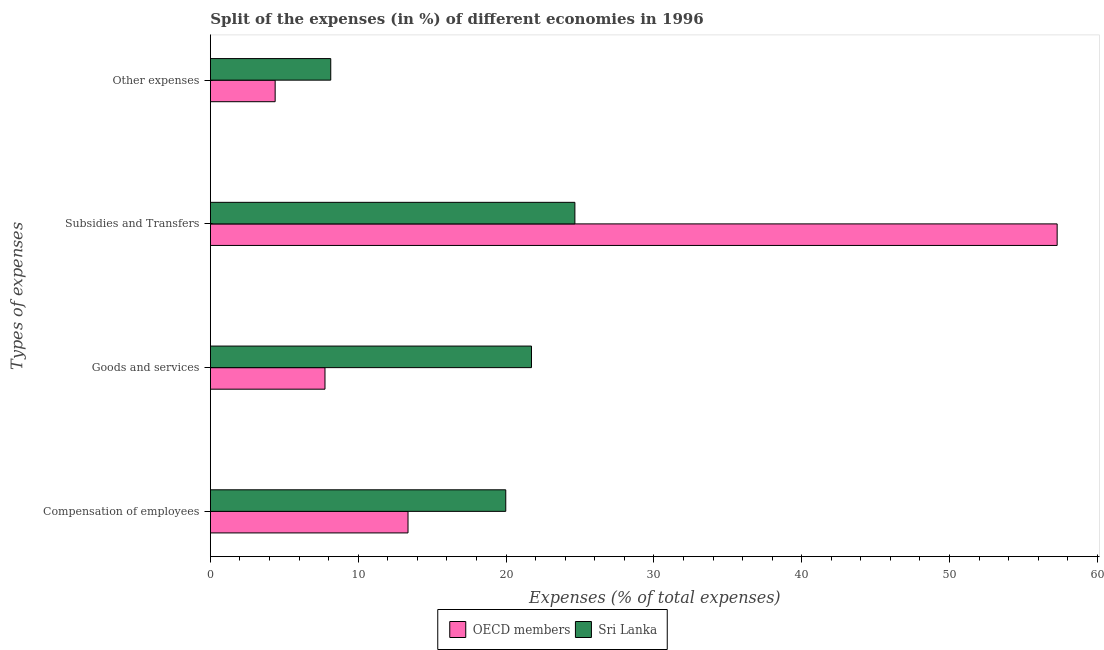How many groups of bars are there?
Your response must be concise. 4. Are the number of bars on each tick of the Y-axis equal?
Give a very brief answer. Yes. How many bars are there on the 3rd tick from the top?
Your answer should be very brief. 2. How many bars are there on the 4th tick from the bottom?
Keep it short and to the point. 2. What is the label of the 2nd group of bars from the top?
Your answer should be compact. Subsidies and Transfers. What is the percentage of amount spent on other expenses in Sri Lanka?
Your answer should be very brief. 8.14. Across all countries, what is the maximum percentage of amount spent on goods and services?
Offer a terse response. 21.72. Across all countries, what is the minimum percentage of amount spent on other expenses?
Make the answer very short. 4.38. In which country was the percentage of amount spent on compensation of employees maximum?
Your answer should be very brief. Sri Lanka. In which country was the percentage of amount spent on other expenses minimum?
Keep it short and to the point. OECD members. What is the total percentage of amount spent on subsidies in the graph?
Provide a short and direct response. 81.94. What is the difference between the percentage of amount spent on compensation of employees in OECD members and that in Sri Lanka?
Your answer should be compact. -6.61. What is the difference between the percentage of amount spent on goods and services in OECD members and the percentage of amount spent on other expenses in Sri Lanka?
Provide a short and direct response. -0.39. What is the average percentage of amount spent on goods and services per country?
Your answer should be compact. 14.74. What is the difference between the percentage of amount spent on goods and services and percentage of amount spent on compensation of employees in Sri Lanka?
Give a very brief answer. 1.74. What is the ratio of the percentage of amount spent on subsidies in OECD members to that in Sri Lanka?
Your answer should be compact. 2.32. What is the difference between the highest and the second highest percentage of amount spent on goods and services?
Give a very brief answer. 13.97. What is the difference between the highest and the lowest percentage of amount spent on goods and services?
Your response must be concise. 13.97. What does the 2nd bar from the top in Compensation of employees represents?
Make the answer very short. OECD members. Is it the case that in every country, the sum of the percentage of amount spent on compensation of employees and percentage of amount spent on goods and services is greater than the percentage of amount spent on subsidies?
Make the answer very short. No. What is the difference between two consecutive major ticks on the X-axis?
Your answer should be compact. 10. Are the values on the major ticks of X-axis written in scientific E-notation?
Give a very brief answer. No. Does the graph contain grids?
Ensure brevity in your answer.  No. How many legend labels are there?
Give a very brief answer. 2. How are the legend labels stacked?
Make the answer very short. Horizontal. What is the title of the graph?
Ensure brevity in your answer.  Split of the expenses (in %) of different economies in 1996. What is the label or title of the X-axis?
Provide a succinct answer. Expenses (% of total expenses). What is the label or title of the Y-axis?
Your answer should be very brief. Types of expenses. What is the Expenses (% of total expenses) of OECD members in Compensation of employees?
Provide a short and direct response. 13.37. What is the Expenses (% of total expenses) in Sri Lanka in Compensation of employees?
Offer a very short reply. 19.98. What is the Expenses (% of total expenses) of OECD members in Goods and services?
Your answer should be compact. 7.75. What is the Expenses (% of total expenses) of Sri Lanka in Goods and services?
Make the answer very short. 21.72. What is the Expenses (% of total expenses) in OECD members in Subsidies and Transfers?
Your answer should be very brief. 57.28. What is the Expenses (% of total expenses) in Sri Lanka in Subsidies and Transfers?
Make the answer very short. 24.66. What is the Expenses (% of total expenses) in OECD members in Other expenses?
Ensure brevity in your answer.  4.38. What is the Expenses (% of total expenses) in Sri Lanka in Other expenses?
Provide a short and direct response. 8.14. Across all Types of expenses, what is the maximum Expenses (% of total expenses) in OECD members?
Your answer should be compact. 57.28. Across all Types of expenses, what is the maximum Expenses (% of total expenses) in Sri Lanka?
Your answer should be compact. 24.66. Across all Types of expenses, what is the minimum Expenses (% of total expenses) in OECD members?
Offer a terse response. 4.38. Across all Types of expenses, what is the minimum Expenses (% of total expenses) in Sri Lanka?
Offer a very short reply. 8.14. What is the total Expenses (% of total expenses) in OECD members in the graph?
Your answer should be very brief. 82.78. What is the total Expenses (% of total expenses) in Sri Lanka in the graph?
Your response must be concise. 74.5. What is the difference between the Expenses (% of total expenses) in OECD members in Compensation of employees and that in Goods and services?
Offer a very short reply. 5.62. What is the difference between the Expenses (% of total expenses) of Sri Lanka in Compensation of employees and that in Goods and services?
Provide a succinct answer. -1.74. What is the difference between the Expenses (% of total expenses) of OECD members in Compensation of employees and that in Subsidies and Transfers?
Give a very brief answer. -43.91. What is the difference between the Expenses (% of total expenses) in Sri Lanka in Compensation of employees and that in Subsidies and Transfers?
Make the answer very short. -4.68. What is the difference between the Expenses (% of total expenses) in OECD members in Compensation of employees and that in Other expenses?
Provide a succinct answer. 8.99. What is the difference between the Expenses (% of total expenses) in Sri Lanka in Compensation of employees and that in Other expenses?
Provide a short and direct response. 11.84. What is the difference between the Expenses (% of total expenses) in OECD members in Goods and services and that in Subsidies and Transfers?
Give a very brief answer. -49.53. What is the difference between the Expenses (% of total expenses) of Sri Lanka in Goods and services and that in Subsidies and Transfers?
Your answer should be compact. -2.94. What is the difference between the Expenses (% of total expenses) in OECD members in Goods and services and that in Other expenses?
Offer a terse response. 3.37. What is the difference between the Expenses (% of total expenses) in Sri Lanka in Goods and services and that in Other expenses?
Keep it short and to the point. 13.58. What is the difference between the Expenses (% of total expenses) in OECD members in Subsidies and Transfers and that in Other expenses?
Ensure brevity in your answer.  52.9. What is the difference between the Expenses (% of total expenses) in Sri Lanka in Subsidies and Transfers and that in Other expenses?
Give a very brief answer. 16.51. What is the difference between the Expenses (% of total expenses) of OECD members in Compensation of employees and the Expenses (% of total expenses) of Sri Lanka in Goods and services?
Keep it short and to the point. -8.35. What is the difference between the Expenses (% of total expenses) of OECD members in Compensation of employees and the Expenses (% of total expenses) of Sri Lanka in Subsidies and Transfers?
Your answer should be compact. -11.29. What is the difference between the Expenses (% of total expenses) of OECD members in Compensation of employees and the Expenses (% of total expenses) of Sri Lanka in Other expenses?
Provide a succinct answer. 5.23. What is the difference between the Expenses (% of total expenses) in OECD members in Goods and services and the Expenses (% of total expenses) in Sri Lanka in Subsidies and Transfers?
Keep it short and to the point. -16.9. What is the difference between the Expenses (% of total expenses) in OECD members in Goods and services and the Expenses (% of total expenses) in Sri Lanka in Other expenses?
Provide a short and direct response. -0.39. What is the difference between the Expenses (% of total expenses) of OECD members in Subsidies and Transfers and the Expenses (% of total expenses) of Sri Lanka in Other expenses?
Offer a very short reply. 49.14. What is the average Expenses (% of total expenses) in OECD members per Types of expenses?
Give a very brief answer. 20.7. What is the average Expenses (% of total expenses) of Sri Lanka per Types of expenses?
Provide a short and direct response. 18.62. What is the difference between the Expenses (% of total expenses) in OECD members and Expenses (% of total expenses) in Sri Lanka in Compensation of employees?
Your response must be concise. -6.61. What is the difference between the Expenses (% of total expenses) of OECD members and Expenses (% of total expenses) of Sri Lanka in Goods and services?
Offer a very short reply. -13.97. What is the difference between the Expenses (% of total expenses) in OECD members and Expenses (% of total expenses) in Sri Lanka in Subsidies and Transfers?
Give a very brief answer. 32.62. What is the difference between the Expenses (% of total expenses) of OECD members and Expenses (% of total expenses) of Sri Lanka in Other expenses?
Ensure brevity in your answer.  -3.76. What is the ratio of the Expenses (% of total expenses) of OECD members in Compensation of employees to that in Goods and services?
Your answer should be compact. 1.72. What is the ratio of the Expenses (% of total expenses) in Sri Lanka in Compensation of employees to that in Goods and services?
Offer a very short reply. 0.92. What is the ratio of the Expenses (% of total expenses) of OECD members in Compensation of employees to that in Subsidies and Transfers?
Your response must be concise. 0.23. What is the ratio of the Expenses (% of total expenses) in Sri Lanka in Compensation of employees to that in Subsidies and Transfers?
Keep it short and to the point. 0.81. What is the ratio of the Expenses (% of total expenses) of OECD members in Compensation of employees to that in Other expenses?
Give a very brief answer. 3.05. What is the ratio of the Expenses (% of total expenses) in Sri Lanka in Compensation of employees to that in Other expenses?
Your answer should be very brief. 2.45. What is the ratio of the Expenses (% of total expenses) of OECD members in Goods and services to that in Subsidies and Transfers?
Provide a short and direct response. 0.14. What is the ratio of the Expenses (% of total expenses) of Sri Lanka in Goods and services to that in Subsidies and Transfers?
Provide a succinct answer. 0.88. What is the ratio of the Expenses (% of total expenses) in OECD members in Goods and services to that in Other expenses?
Your answer should be very brief. 1.77. What is the ratio of the Expenses (% of total expenses) in Sri Lanka in Goods and services to that in Other expenses?
Give a very brief answer. 2.67. What is the ratio of the Expenses (% of total expenses) of OECD members in Subsidies and Transfers to that in Other expenses?
Give a very brief answer. 13.07. What is the ratio of the Expenses (% of total expenses) in Sri Lanka in Subsidies and Transfers to that in Other expenses?
Keep it short and to the point. 3.03. What is the difference between the highest and the second highest Expenses (% of total expenses) of OECD members?
Offer a very short reply. 43.91. What is the difference between the highest and the second highest Expenses (% of total expenses) in Sri Lanka?
Your answer should be very brief. 2.94. What is the difference between the highest and the lowest Expenses (% of total expenses) of OECD members?
Offer a very short reply. 52.9. What is the difference between the highest and the lowest Expenses (% of total expenses) of Sri Lanka?
Your answer should be very brief. 16.51. 